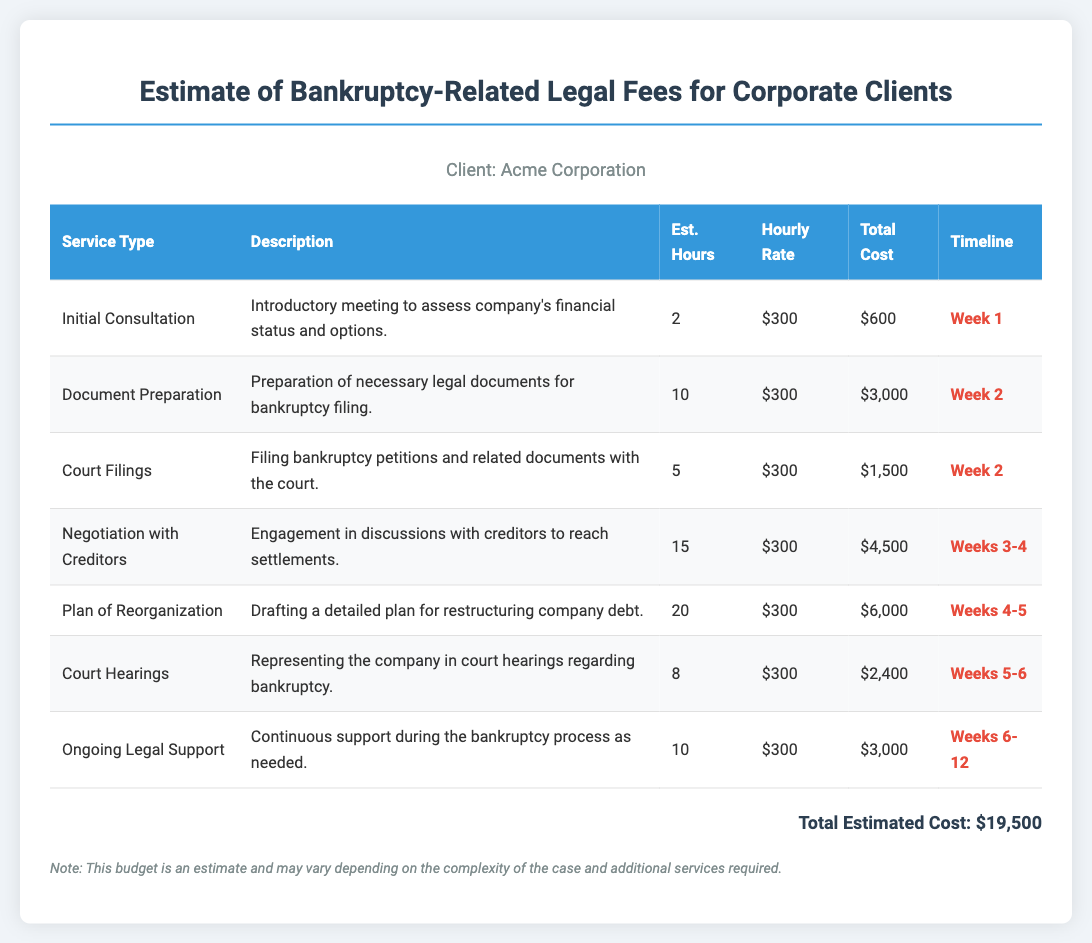What is the total estimated cost? The total estimated cost is listed at the end of the document as $19,500.
Answer: $19,500 How many hours are estimated for Document Preparation? The estimated hours for Document Preparation are found in the table under the "Est. Hours" column, which shows 10 hours.
Answer: 10 What service type is scheduled for Week 1? The service scheduled for Week 1 is "Initial Consultation," which is detailed in the table.
Answer: Initial Consultation How much is the hourly rate for the services? The hourly rate for all services listed in the document is consistently $300 as shown in the table.
Answer: $300 During which weeks is Ongoing Legal Support provided? Ongoing Legal Support is provided from Weeks 6 to 12, as indicated in the timeline column of the table.
Answer: Weeks 6-12 Which service type has the highest total cost? The service with the highest total cost is the "Plan of Reorganization," totaling $6,000 according to the total cost column.
Answer: Plan of Reorganization What is the estimated hours for Court Hearings? The estimated hours for Court Hearings, as shown in the table, is 8 hours.
Answer: 8 What is the purpose of the Initial Consultation? The purpose of the Initial Consultation is to assess the company's financial status and options, detailed in the description column.
Answer: Assess company's financial status and options Which timeline includes Negotiation with Creditors? Negotiation with Creditors occurs in Weeks 3-4, as specified in the timeline column of the document.
Answer: Weeks 3-4 